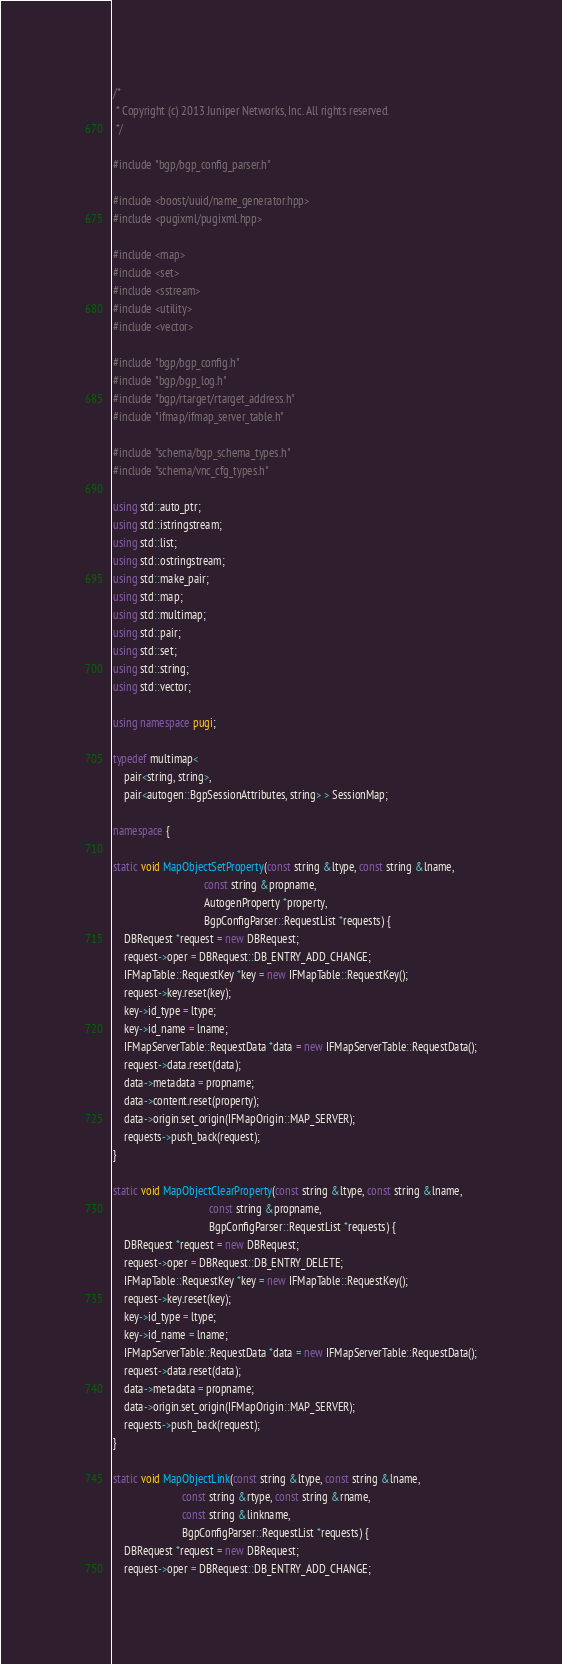Convert code to text. <code><loc_0><loc_0><loc_500><loc_500><_C++_>/*
 * Copyright (c) 2013 Juniper Networks, Inc. All rights reserved.
 */

#include "bgp/bgp_config_parser.h"

#include <boost/uuid/name_generator.hpp>
#include <pugixml/pugixml.hpp>

#include <map>
#include <set>
#include <sstream>
#include <utility>
#include <vector>

#include "bgp/bgp_config.h"
#include "bgp/bgp_log.h"
#include "bgp/rtarget/rtarget_address.h"
#include "ifmap/ifmap_server_table.h"

#include "schema/bgp_schema_types.h"
#include "schema/vnc_cfg_types.h"

using std::auto_ptr;
using std::istringstream;
using std::list;
using std::ostringstream;
using std::make_pair;
using std::map;
using std::multimap;
using std::pair;
using std::set;
using std::string;
using std::vector;

using namespace pugi;

typedef multimap<
    pair<string, string>,
    pair<autogen::BgpSessionAttributes, string> > SessionMap;

namespace {

static void MapObjectSetProperty(const string &ltype, const string &lname,
                                 const string &propname,
                                 AutogenProperty *property,
                                 BgpConfigParser::RequestList *requests) {
    DBRequest *request = new DBRequest;
    request->oper = DBRequest::DB_ENTRY_ADD_CHANGE;
    IFMapTable::RequestKey *key = new IFMapTable::RequestKey();
    request->key.reset(key);
    key->id_type = ltype;
    key->id_name = lname;
    IFMapServerTable::RequestData *data = new IFMapServerTable::RequestData();
    request->data.reset(data);
    data->metadata = propname;
    data->content.reset(property);
    data->origin.set_origin(IFMapOrigin::MAP_SERVER);
    requests->push_back(request);
}

static void MapObjectClearProperty(const string &ltype, const string &lname,
                                   const string &propname,
                                   BgpConfigParser::RequestList *requests) {
    DBRequest *request = new DBRequest;
    request->oper = DBRequest::DB_ENTRY_DELETE;
    IFMapTable::RequestKey *key = new IFMapTable::RequestKey();
    request->key.reset(key);
    key->id_type = ltype;
    key->id_name = lname;
    IFMapServerTable::RequestData *data = new IFMapServerTable::RequestData();
    request->data.reset(data);
    data->metadata = propname;
    data->origin.set_origin(IFMapOrigin::MAP_SERVER);
    requests->push_back(request);
}

static void MapObjectLink(const string &ltype, const string &lname,
                         const string &rtype, const string &rname,
                         const string &linkname,
                         BgpConfigParser::RequestList *requests) {
    DBRequest *request = new DBRequest;
    request->oper = DBRequest::DB_ENTRY_ADD_CHANGE;</code> 